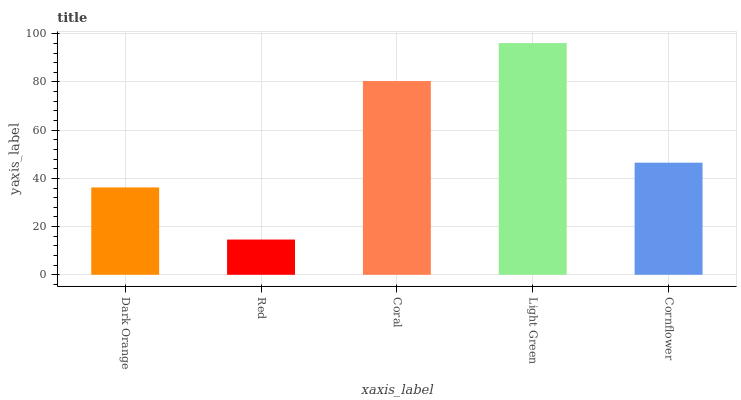Is Coral the minimum?
Answer yes or no. No. Is Coral the maximum?
Answer yes or no. No. Is Coral greater than Red?
Answer yes or no. Yes. Is Red less than Coral?
Answer yes or no. Yes. Is Red greater than Coral?
Answer yes or no. No. Is Coral less than Red?
Answer yes or no. No. Is Cornflower the high median?
Answer yes or no. Yes. Is Cornflower the low median?
Answer yes or no. Yes. Is Coral the high median?
Answer yes or no. No. Is Red the low median?
Answer yes or no. No. 